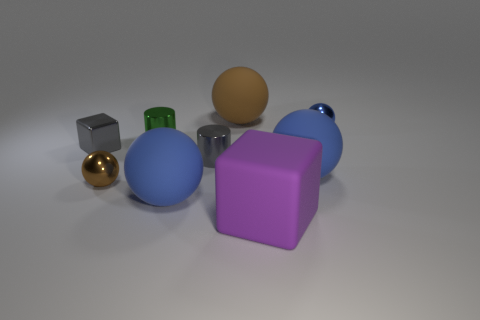Does the green metallic thing have the same shape as the large blue object that is to the left of the brown rubber sphere?
Make the answer very short. No. There is a tiny thing that is both to the left of the green cylinder and to the right of the metal block; what is it made of?
Your answer should be very brief. Metal. What color is the cylinder that is the same size as the green thing?
Make the answer very short. Gray. Do the green cylinder and the brown sphere behind the small blue ball have the same material?
Your response must be concise. No. How many other objects are the same size as the green object?
Make the answer very short. 4. Are there any brown rubber spheres that are in front of the large blue ball behind the shiny ball that is left of the big rubber cube?
Your answer should be very brief. No. What size is the purple matte object?
Offer a very short reply. Large. There is a metallic ball in front of the tiny blue shiny ball; what size is it?
Offer a very short reply. Small. There is a green metallic cylinder left of the purple rubber thing; does it have the same size as the large matte block?
Your answer should be compact. No. Is there any other thing that is the same color as the metal cube?
Your answer should be very brief. Yes. 